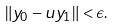<formula> <loc_0><loc_0><loc_500><loc_500>\| y _ { 0 } - u y _ { 1 } \| < \epsilon .</formula> 